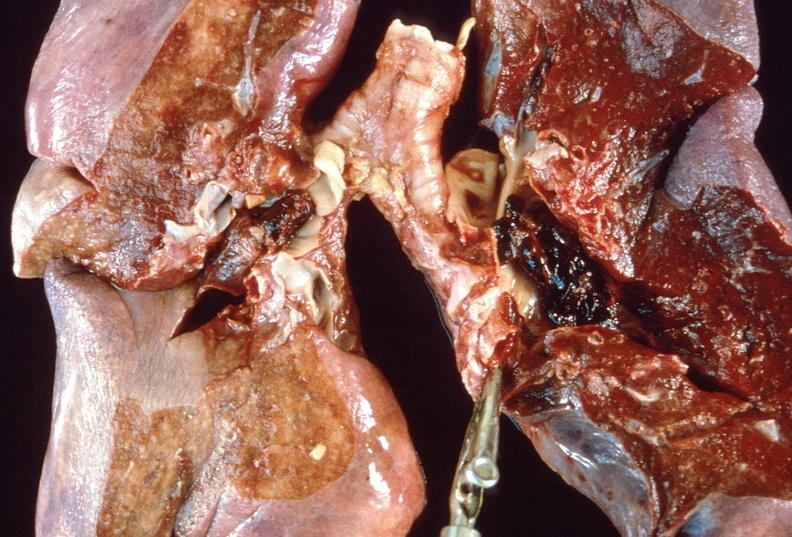where is this?
Answer the question using a single word or phrase. Lung 